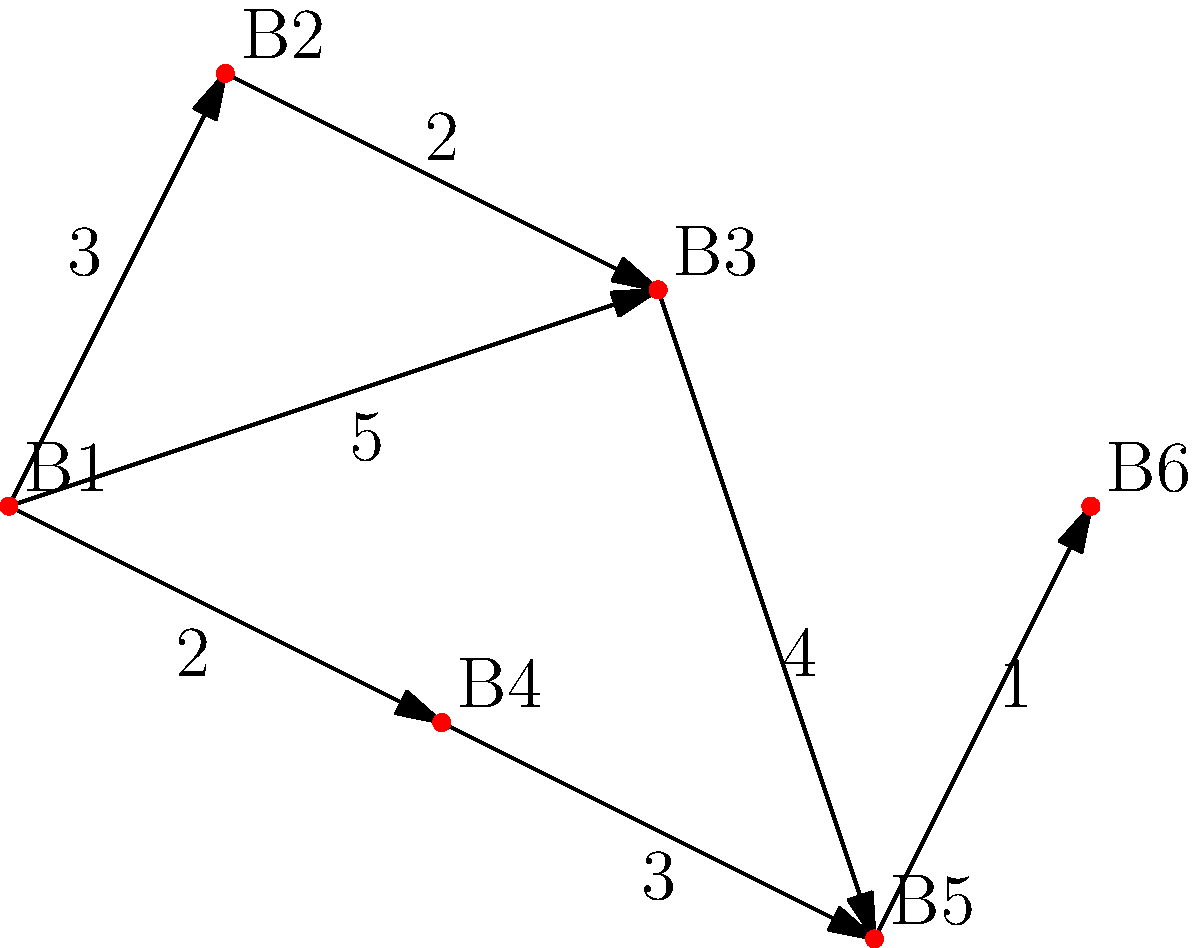As a marketing expert promoting craft beer, you're organizing a brewery tour in a city. The map above shows six craft breweries (B1 to B6) and the travel times between them in minutes. What's the shortest time path from brewery B1 to B6, and how long does it take? To find the shortest path from B1 to B6, we'll use Dijkstra's algorithm:

1. Start at B1 with a distance of 0.
2. Examine neighbors of B1:
   - B2: distance 3
   - B3: distance 5
   - B4: distance 2
3. Choose B4 as it has the shortest distance (2).
4. Examine neighbors of B4:
   - B5: distance 2 + 3 = 5
5. Compare B2 (3) and B3 (5). Choose B2.
6. Examine neighbors of B2:
   - B3: distance 3 + 2 = 5 (no improvement)
7. Choose B5 (distance 5).
8. Examine neighbors of B5:
   - B6: distance 5 + 1 = 6
9. Choose B6 (distance 6).

The shortest path is B1 → B4 → B5 → B6, with a total time of 6 minutes.
Answer: B1 → B4 → B5 → B6, 6 minutes 